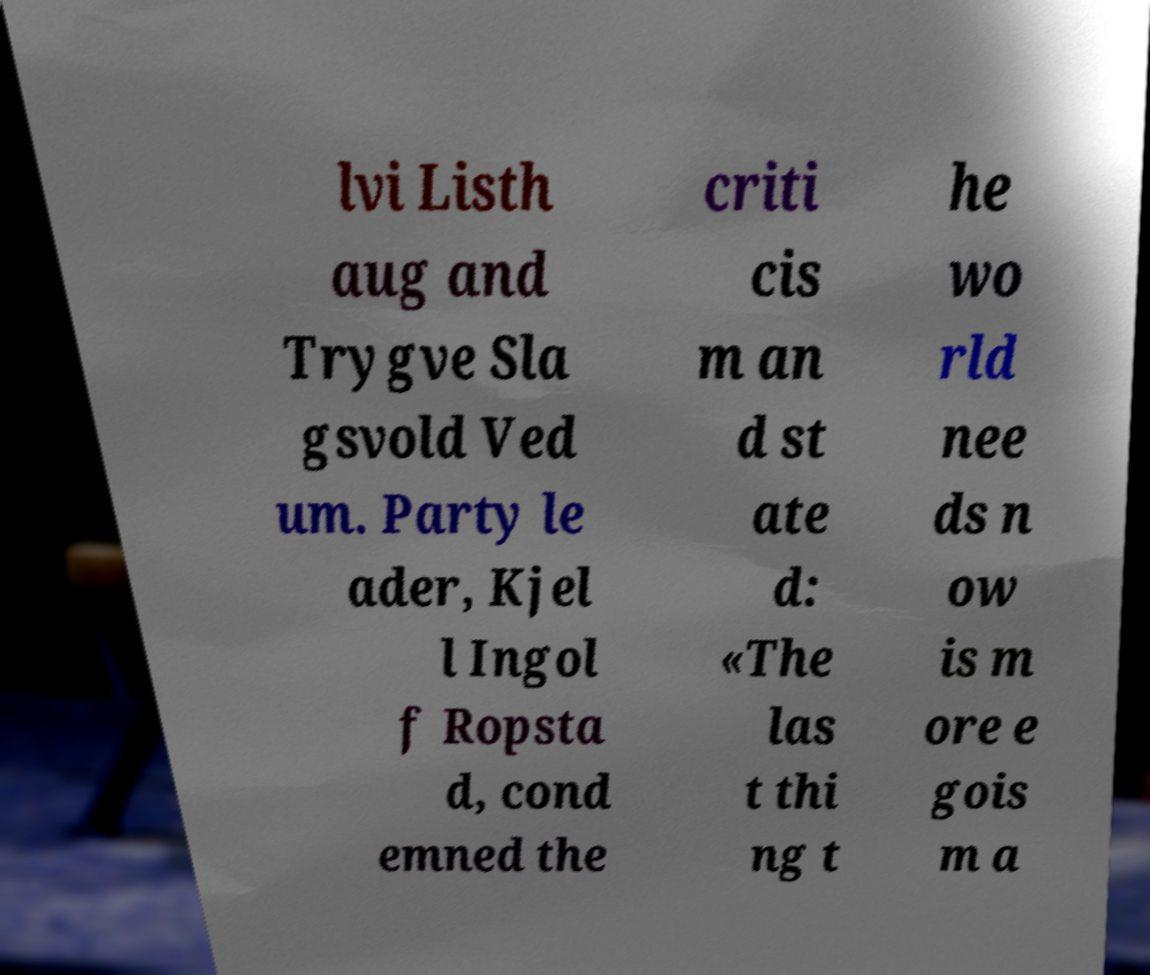For documentation purposes, I need the text within this image transcribed. Could you provide that? lvi Listh aug and Trygve Sla gsvold Ved um. Party le ader, Kjel l Ingol f Ropsta d, cond emned the criti cis m an d st ate d: «The las t thi ng t he wo rld nee ds n ow is m ore e gois m a 